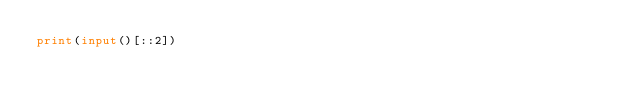<code> <loc_0><loc_0><loc_500><loc_500><_Python_>print(input()[::2])</code> 